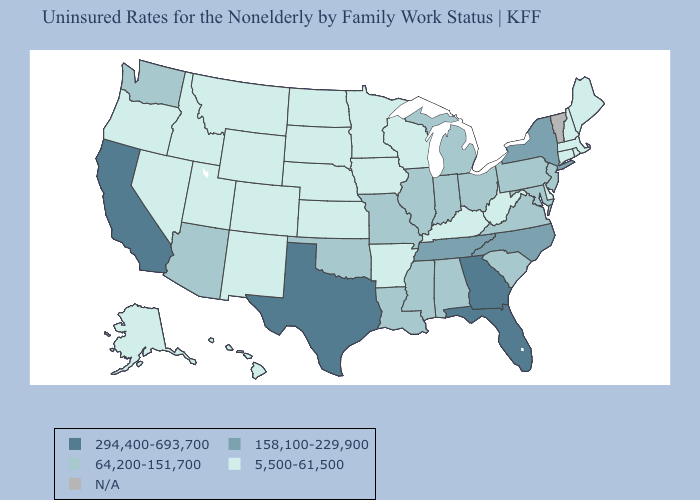Which states have the lowest value in the USA?
Concise answer only. Alaska, Arkansas, Colorado, Connecticut, Delaware, Hawaii, Idaho, Iowa, Kansas, Kentucky, Maine, Massachusetts, Minnesota, Montana, Nebraska, Nevada, New Hampshire, New Mexico, North Dakota, Oregon, Rhode Island, South Dakota, Utah, West Virginia, Wisconsin, Wyoming. Which states have the highest value in the USA?
Concise answer only. California, Florida, Georgia, Texas. Name the states that have a value in the range N/A?
Quick response, please. Vermont. What is the highest value in states that border Wisconsin?
Be succinct. 64,200-151,700. Which states have the lowest value in the MidWest?
Be succinct. Iowa, Kansas, Minnesota, Nebraska, North Dakota, South Dakota, Wisconsin. What is the highest value in the Northeast ?
Keep it brief. 158,100-229,900. Name the states that have a value in the range 5,500-61,500?
Concise answer only. Alaska, Arkansas, Colorado, Connecticut, Delaware, Hawaii, Idaho, Iowa, Kansas, Kentucky, Maine, Massachusetts, Minnesota, Montana, Nebraska, Nevada, New Hampshire, New Mexico, North Dakota, Oregon, Rhode Island, South Dakota, Utah, West Virginia, Wisconsin, Wyoming. Among the states that border Washington , which have the lowest value?
Keep it brief. Idaho, Oregon. Does the first symbol in the legend represent the smallest category?
Keep it brief. No. What is the value of Mississippi?
Keep it brief. 64,200-151,700. What is the lowest value in the South?
Answer briefly. 5,500-61,500. What is the value of Massachusetts?
Quick response, please. 5,500-61,500. What is the lowest value in the South?
Quick response, please. 5,500-61,500. What is the lowest value in the West?
Keep it brief. 5,500-61,500. 